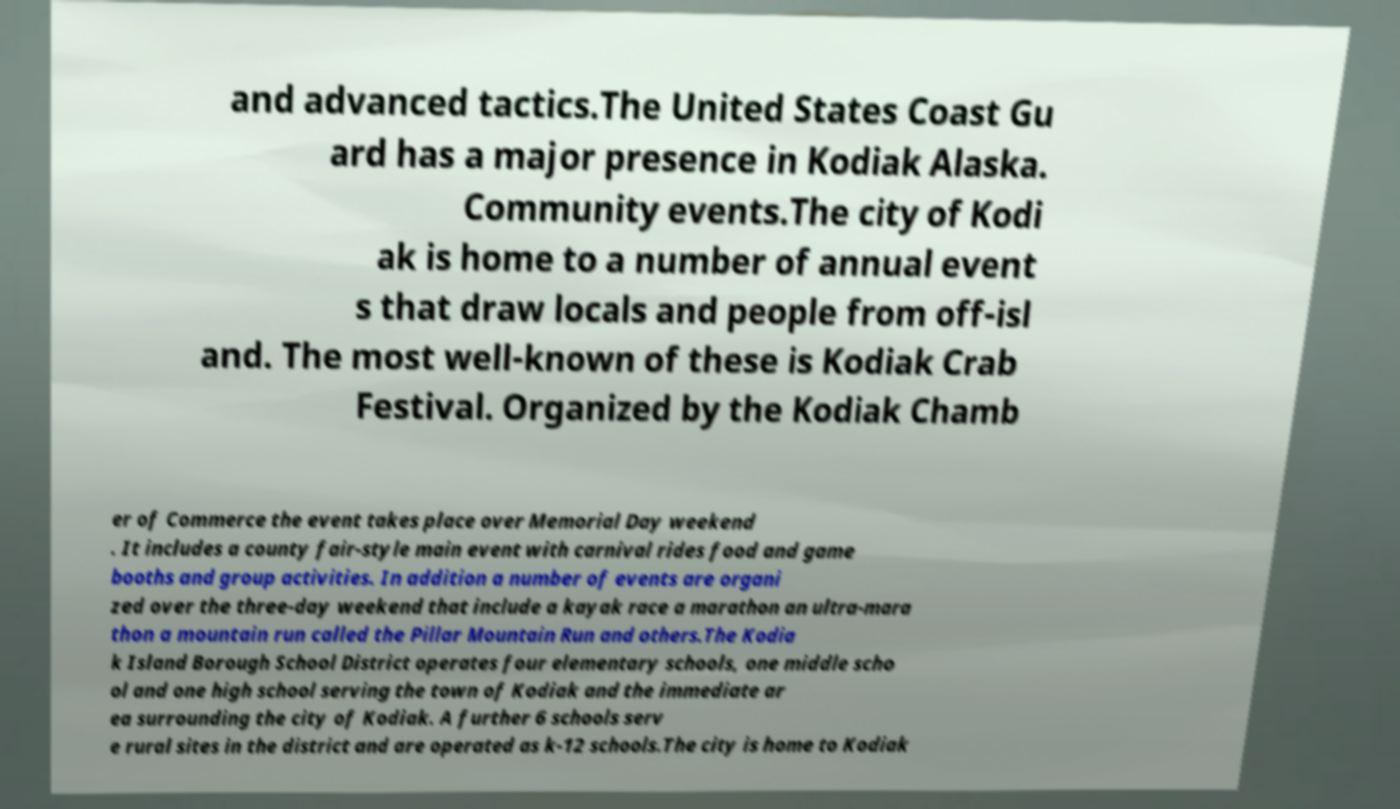There's text embedded in this image that I need extracted. Can you transcribe it verbatim? and advanced tactics.The United States Coast Gu ard has a major presence in Kodiak Alaska. Community events.The city of Kodi ak is home to a number of annual event s that draw locals and people from off-isl and. The most well-known of these is Kodiak Crab Festival. Organized by the Kodiak Chamb er of Commerce the event takes place over Memorial Day weekend . It includes a county fair-style main event with carnival rides food and game booths and group activities. In addition a number of events are organi zed over the three-day weekend that include a kayak race a marathon an ultra-mara thon a mountain run called the Pillar Mountain Run and others.The Kodia k Island Borough School District operates four elementary schools, one middle scho ol and one high school serving the town of Kodiak and the immediate ar ea surrounding the city of Kodiak. A further 6 schools serv e rural sites in the district and are operated as k-12 schools.The city is home to Kodiak 